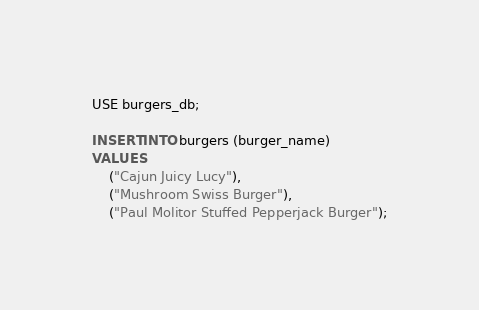<code> <loc_0><loc_0><loc_500><loc_500><_SQL_>USE burgers_db;

INSERT INTO burgers (burger_name)
VALUES 
    ("Cajun Juicy Lucy"),
    ("Mushroom Swiss Burger"),
    ("Paul Molitor Stuffed Pepperjack Burger");</code> 